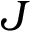Convert formula to latex. <formula><loc_0><loc_0><loc_500><loc_500>J</formula> 